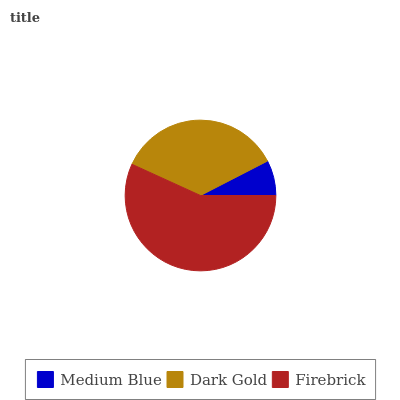Is Medium Blue the minimum?
Answer yes or no. Yes. Is Firebrick the maximum?
Answer yes or no. Yes. Is Dark Gold the minimum?
Answer yes or no. No. Is Dark Gold the maximum?
Answer yes or no. No. Is Dark Gold greater than Medium Blue?
Answer yes or no. Yes. Is Medium Blue less than Dark Gold?
Answer yes or no. Yes. Is Medium Blue greater than Dark Gold?
Answer yes or no. No. Is Dark Gold less than Medium Blue?
Answer yes or no. No. Is Dark Gold the high median?
Answer yes or no. Yes. Is Dark Gold the low median?
Answer yes or no. Yes. Is Medium Blue the high median?
Answer yes or no. No. Is Firebrick the low median?
Answer yes or no. No. 